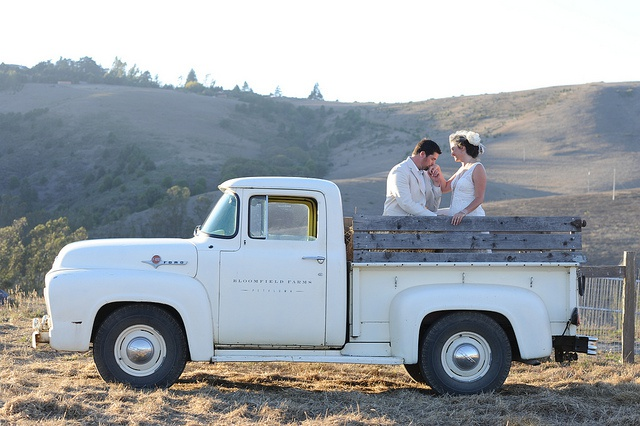Describe the objects in this image and their specific colors. I can see truck in white, lightblue, black, and darkgray tones, people in white, darkgray, and gray tones, and people in white, darkgray, and gray tones in this image. 